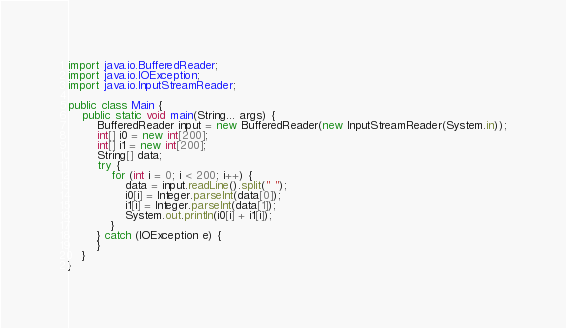<code> <loc_0><loc_0><loc_500><loc_500><_Java_>import java.io.BufferedReader;
import java.io.IOException;
import java.io.InputStreamReader;

public class Main {
    public static void main(String... args) {
        BufferedReader input = new BufferedReader(new InputStreamReader(System.in));
        int[] i0 = new int[200];
        int[] i1 = new int[200];
        String[] data;
        try {
            for (int i = 0; i < 200; i++) {
                data = input.readLine().split(" ");
                i0[i] = Integer.parseInt(data[0]);
                i1[i] = Integer.parseInt(data[1]);
                System.out.println(i0[i] + i1[i]);
            }
        } catch (IOException e) {
        }
    }
}</code> 